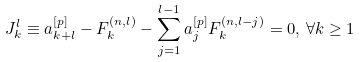Convert formula to latex. <formula><loc_0><loc_0><loc_500><loc_500>J _ { k } ^ { l } \equiv a ^ { [ p ] } _ { k + l } - F _ { k } ^ { ( n , l ) } - \sum _ { j = 1 } ^ { l - 1 } a _ { j } ^ { [ p ] } F _ { k } ^ { ( n , l - j ) } = 0 , \, \forall k \geq 1</formula> 